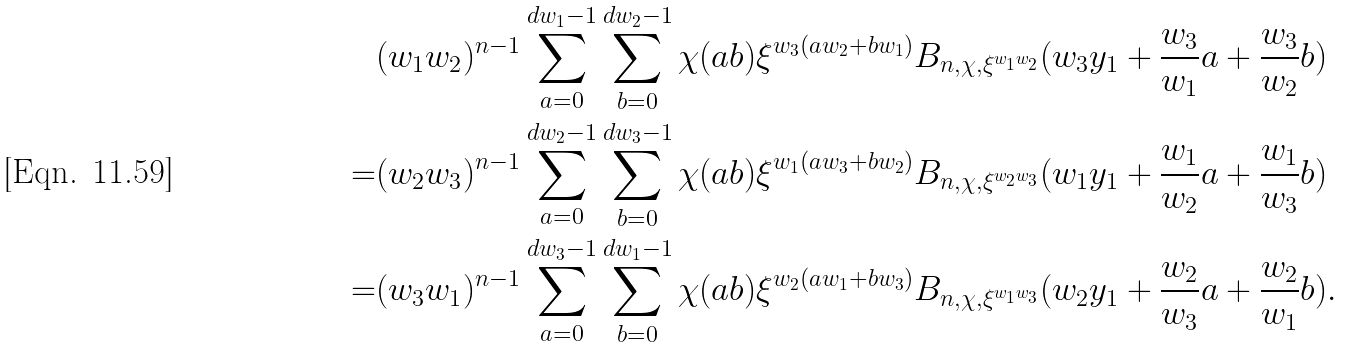<formula> <loc_0><loc_0><loc_500><loc_500>& ( w _ { 1 } w _ { 2 } ) ^ { n - 1 } \sum _ { a = 0 } ^ { d w _ { 1 } - 1 } \sum _ { b = 0 } ^ { d w _ { 2 } - 1 } \chi ( a b ) \xi ^ { w _ { 3 } ( a w _ { 2 } + b w _ { 1 } ) } B _ { n , \chi , \xi ^ { w _ { 1 } w _ { 2 } } } ( w _ { 3 } y _ { 1 } + \frac { w _ { 3 } } { w _ { 1 } } a + \frac { w _ { 3 } } { w _ { 2 } } b ) \\ = & ( w _ { 2 } w _ { 3 } ) ^ { n - 1 } \sum _ { a = 0 } ^ { d w _ { 2 } - 1 } \sum _ { b = 0 } ^ { d w _ { 3 } - 1 } \chi ( a b ) \xi ^ { w _ { 1 } ( a w _ { 3 } + b w _ { 2 } ) } B _ { n , \chi , \xi ^ { w _ { 2 } w _ { 3 } } } ( w _ { 1 } y _ { 1 } + \frac { w _ { 1 } } { w _ { 2 } } a + \frac { w _ { 1 } } { w _ { 3 } } b ) \\ = & ( w _ { 3 } w _ { 1 } ) ^ { n - 1 } \sum _ { a = 0 } ^ { d w _ { 3 } - 1 } \sum _ { b = 0 } ^ { d w _ { 1 } - 1 } \chi ( a b ) \xi ^ { w _ { 2 } ( a w _ { 1 } + b w _ { 3 } ) } B _ { n , \chi , \xi ^ { w _ { 1 } w _ { 3 } } } ( w _ { 2 } y _ { 1 } + \frac { w _ { 2 } } { w _ { 3 } } a + \frac { w _ { 2 } } { w _ { 1 } } b ) .</formula> 